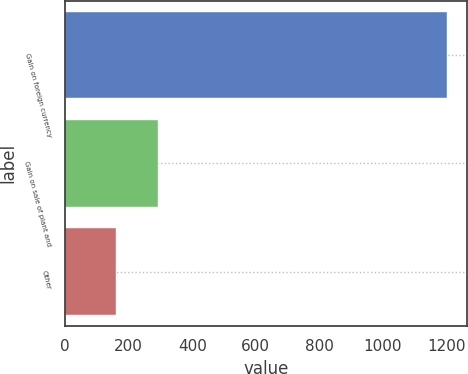Convert chart. <chart><loc_0><loc_0><loc_500><loc_500><bar_chart><fcel>Gain on foreign currency<fcel>Gain on sale of plant and<fcel>Other<nl><fcel>1203<fcel>291<fcel>161<nl></chart> 